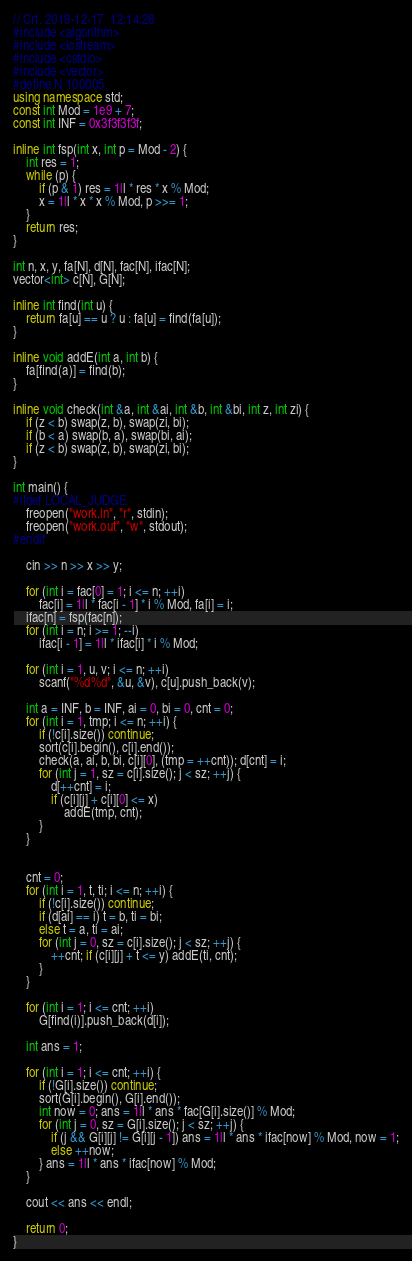<code> <loc_0><loc_0><loc_500><loc_500><_C++_>// Crt. 2019-12-17  12:14:28
#include <algorithm>
#include <iostream>
#include <cstdio>
#include <vector>
#define N 100005
using namespace std;
const int Mod = 1e9 + 7;
const int INF = 0x3f3f3f3f;

inline int fsp(int x, int p = Mod - 2) {
    int res = 1;
    while (p) {
        if (p & 1) res = 1ll * res * x % Mod;
        x = 1ll * x * x % Mod, p >>= 1;
    }
    return res;
}

int n, x, y, fa[N], d[N], fac[N], ifac[N];
vector<int> c[N], G[N];

inline int find(int u) {
    return fa[u] == u ? u : fa[u] = find(fa[u]);
}

inline void addE(int a, int b) {
    fa[find(a)] = find(b);
}

inline void check(int &a, int &ai, int &b, int &bi, int z, int zi) {
    if (z < b) swap(z, b), swap(zi, bi);
    if (b < a) swap(b, a), swap(bi, ai);
    if (z < b) swap(z, b), swap(zi, bi);
}

int main() {
#ifdef LOCAL_JUDGE
    freopen("work.in", "r", stdin);
    freopen("work.out", "w", stdout);
#endif

    cin >> n >> x >> y;
    
    for (int i = fac[0] = 1; i <= n; ++i)
        fac[i] = 1ll * fac[i - 1] * i % Mod, fa[i] = i;
    ifac[n] = fsp(fac[n]);
    for (int i = n; i >= 1; --i)
        ifac[i - 1] = 1ll * ifac[i] * i % Mod;

    for (int i = 1, u, v; i <= n; ++i)
        scanf("%d%d", &u, &v), c[u].push_back(v);

    int a = INF, b = INF, ai = 0, bi = 0, cnt = 0;
    for (int i = 1, tmp; i <= n; ++i) {
        if (!c[i].size()) continue;
        sort(c[i].begin(), c[i].end());
        check(a, ai, b, bi, c[i][0], (tmp = ++cnt)); d[cnt] = i;
        for (int j = 1, sz = c[i].size(); j < sz; ++j) {
            d[++cnt] = i;
            if (c[i][j] + c[i][0] <= x)
                addE(tmp, cnt);
        }
    } 
    

    cnt = 0;
    for (int i = 1, t, ti; i <= n; ++i) {
        if (!c[i].size()) continue;
        if (d[ai] == i) t = b, ti = bi;
        else t = a, ti = ai;
        for (int j = 0, sz = c[i].size(); j < sz; ++j) {
            ++cnt; if (c[i][j] + t <= y) addE(ti, cnt);
        }
    }

    for (int i = 1; i <= cnt; ++i)
        G[find(i)].push_back(d[i]);

    int ans = 1;

    for (int i = 1; i <= cnt; ++i) {
        if (!G[i].size()) continue;
        sort(G[i].begin(), G[i].end());
        int now = 0; ans = 1ll * ans * fac[G[i].size()] % Mod;
        for (int j = 0, sz = G[i].size(); j < sz; ++j) {
            if (j && G[i][j] != G[i][j - 1]) ans = 1ll * ans * ifac[now] % Mod, now = 1;
            else ++now;
        } ans = 1ll * ans * ifac[now] % Mod;
    }

    cout << ans << endl;

    return 0;
}
</code> 